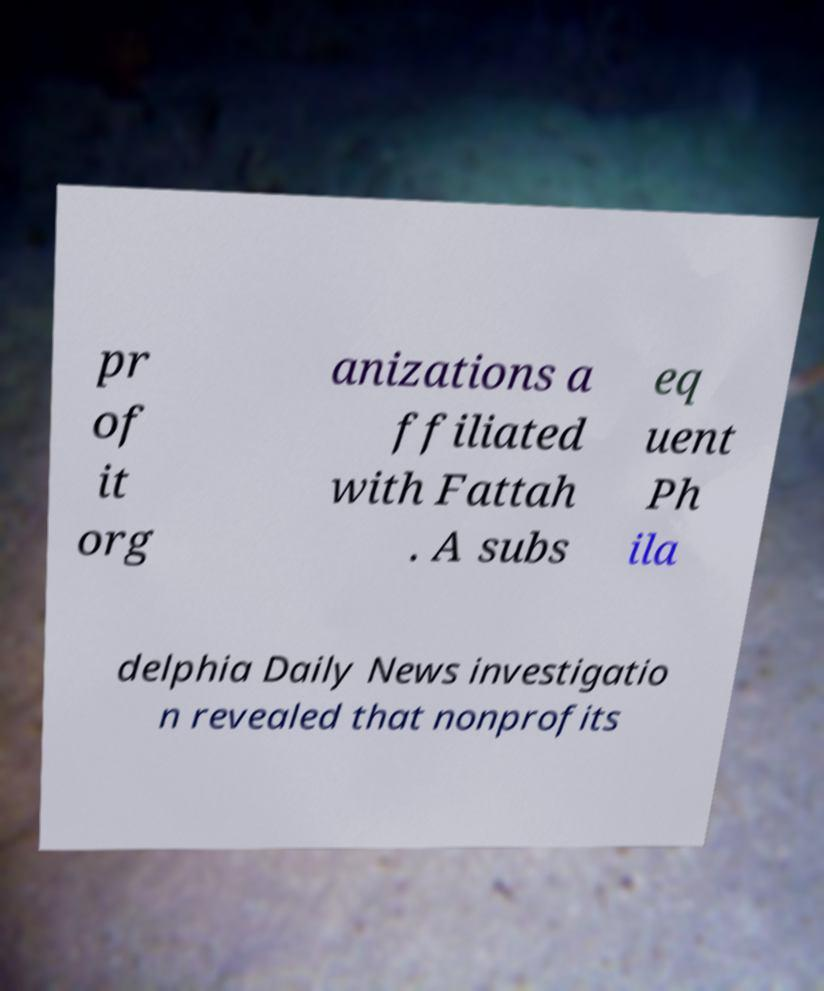Could you extract and type out the text from this image? pr of it org anizations a ffiliated with Fattah . A subs eq uent Ph ila delphia Daily News investigatio n revealed that nonprofits 